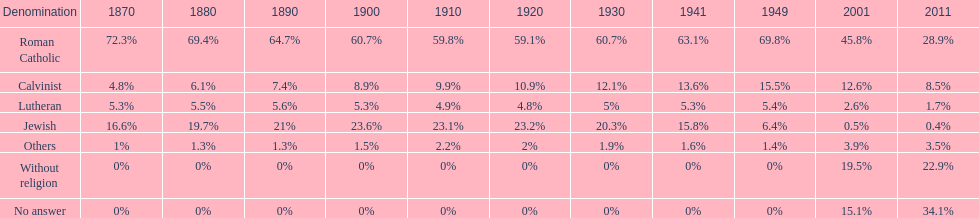What is the biggest religious sect in budapest? Roman Catholic. Would you mind parsing the complete table? {'header': ['Denomination', '1870', '1880', '1890', '1900', '1910', '1920', '1930', '1941', '1949', '2001', '2011'], 'rows': [['Roman Catholic', '72.3%', '69.4%', '64.7%', '60.7%', '59.8%', '59.1%', '60.7%', '63.1%', '69.8%', '45.8%', '28.9%'], ['Calvinist', '4.8%', '6.1%', '7.4%', '8.9%', '9.9%', '10.9%', '12.1%', '13.6%', '15.5%', '12.6%', '8.5%'], ['Lutheran', '5.3%', '5.5%', '5.6%', '5.3%', '4.9%', '4.8%', '5%', '5.3%', '5.4%', '2.6%', '1.7%'], ['Jewish', '16.6%', '19.7%', '21%', '23.6%', '23.1%', '23.2%', '20.3%', '15.8%', '6.4%', '0.5%', '0.4%'], ['Others', '1%', '1.3%', '1.3%', '1.5%', '2.2%', '2%', '1.9%', '1.6%', '1.4%', '3.9%', '3.5%'], ['Without religion', '0%', '0%', '0%', '0%', '0%', '0%', '0%', '0%', '0%', '19.5%', '22.9%'], ['No answer', '0%', '0%', '0%', '0%', '0%', '0%', '0%', '0%', '0%', '15.1%', '34.1%']]} 